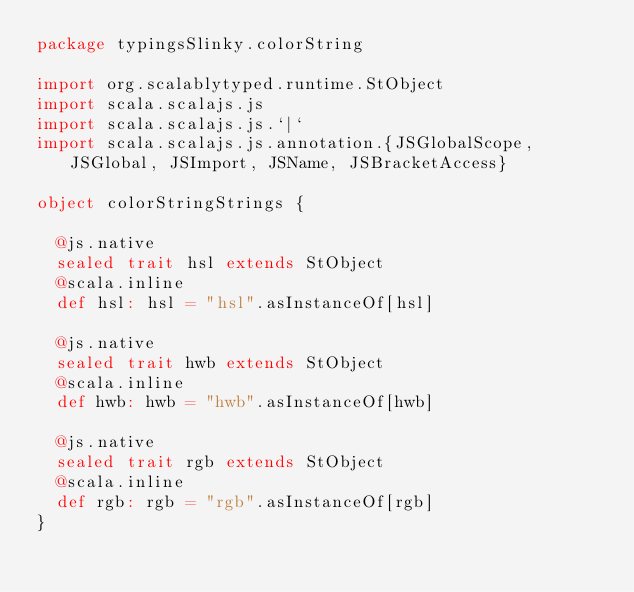<code> <loc_0><loc_0><loc_500><loc_500><_Scala_>package typingsSlinky.colorString

import org.scalablytyped.runtime.StObject
import scala.scalajs.js
import scala.scalajs.js.`|`
import scala.scalajs.js.annotation.{JSGlobalScope, JSGlobal, JSImport, JSName, JSBracketAccess}

object colorStringStrings {
  
  @js.native
  sealed trait hsl extends StObject
  @scala.inline
  def hsl: hsl = "hsl".asInstanceOf[hsl]
  
  @js.native
  sealed trait hwb extends StObject
  @scala.inline
  def hwb: hwb = "hwb".asInstanceOf[hwb]
  
  @js.native
  sealed trait rgb extends StObject
  @scala.inline
  def rgb: rgb = "rgb".asInstanceOf[rgb]
}
</code> 